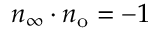Convert formula to latex. <formula><loc_0><loc_0><loc_500><loc_500>n _ { \infty } \cdot n _ { o } = - 1</formula> 